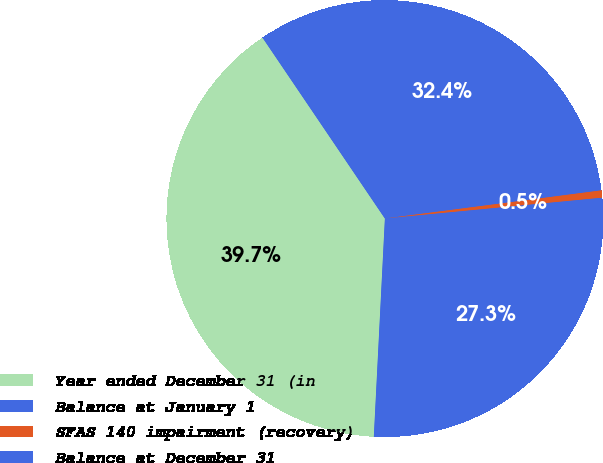<chart> <loc_0><loc_0><loc_500><loc_500><pie_chart><fcel>Year ended December 31 (in<fcel>Balance at January 1<fcel>SFAS 140 impairment (recovery)<fcel>Balance at December 31<nl><fcel>39.73%<fcel>32.41%<fcel>0.54%<fcel>27.33%<nl></chart> 